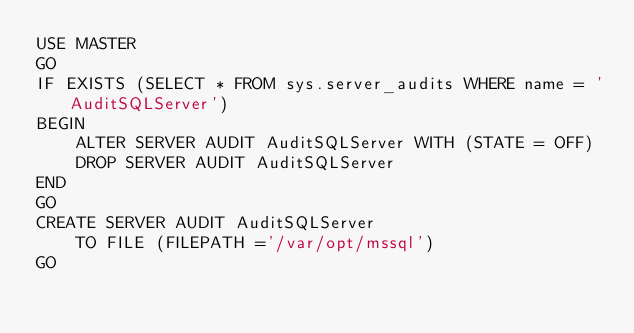<code> <loc_0><loc_0><loc_500><loc_500><_SQL_>USE MASTER
GO
IF EXISTS (SELECT * FROM sys.server_audits WHERE name = 'AuditSQLServer')
BEGIN
    ALTER SERVER AUDIT AuditSQLServer WITH (STATE = OFF)
    DROP SERVER AUDIT AuditSQLServer
END
GO
CREATE SERVER AUDIT AuditSQLServer  
    TO FILE (FILEPATH ='/var/opt/mssql')  
GO</code> 